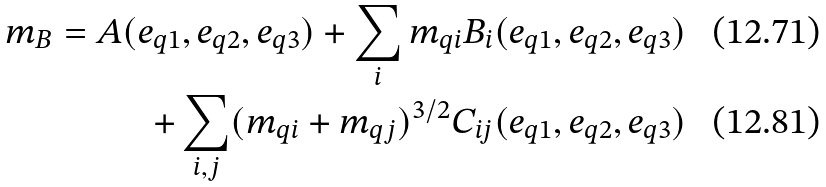<formula> <loc_0><loc_0><loc_500><loc_500>m _ { B } = A ( e _ { q 1 } , e _ { q 2 } , e _ { q 3 } ) + \sum _ { i } m _ { q i } B _ { i } ( e _ { q 1 } , e _ { q 2 } , e _ { q 3 } ) \\ + \sum _ { i , j } ( m _ { q i } + m _ { q j } ) ^ { 3 / 2 } C _ { i j } ( e _ { q 1 } , e _ { q 2 } , e _ { q 3 } )</formula> 